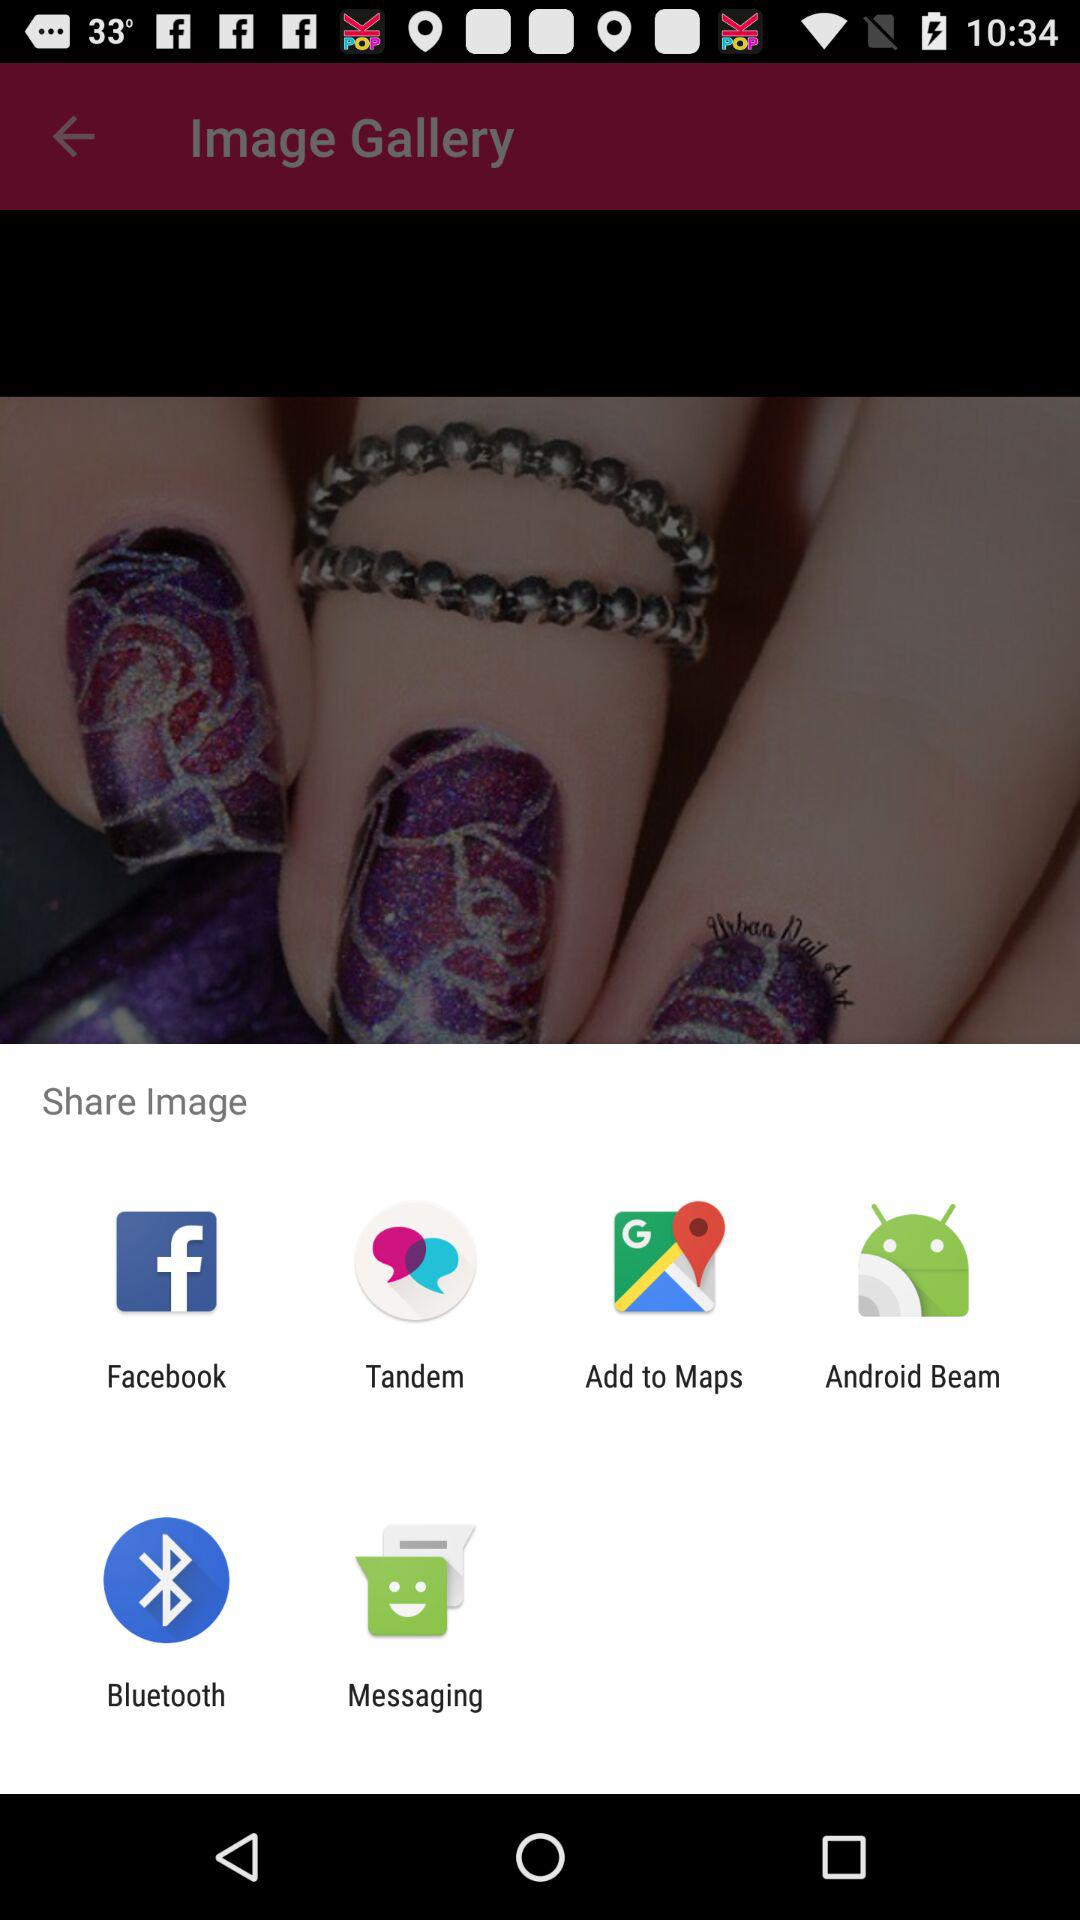Which application can be chosen to share the image? The applications "Facebook", "Tandem", "Add to Maps", "Android Beam", "Bluetooth" and "Messaging" can be chosen to share the image. 